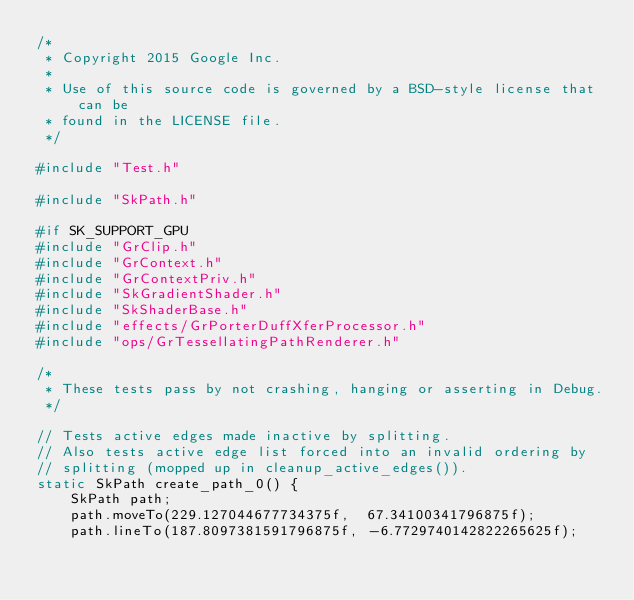<code> <loc_0><loc_0><loc_500><loc_500><_C++_>/*
 * Copyright 2015 Google Inc.
 *
 * Use of this source code is governed by a BSD-style license that can be
 * found in the LICENSE file.
 */

#include "Test.h"

#include "SkPath.h"

#if SK_SUPPORT_GPU
#include "GrClip.h"
#include "GrContext.h"
#include "GrContextPriv.h"
#include "SkGradientShader.h"
#include "SkShaderBase.h"
#include "effects/GrPorterDuffXferProcessor.h"
#include "ops/GrTessellatingPathRenderer.h"

/*
 * These tests pass by not crashing, hanging or asserting in Debug.
 */

// Tests active edges made inactive by splitting.
// Also tests active edge list forced into an invalid ordering by
// splitting (mopped up in cleanup_active_edges()).
static SkPath create_path_0() {
    SkPath path;
    path.moveTo(229.127044677734375f,  67.34100341796875f);
    path.lineTo(187.8097381591796875f, -6.7729740142822265625f);</code> 